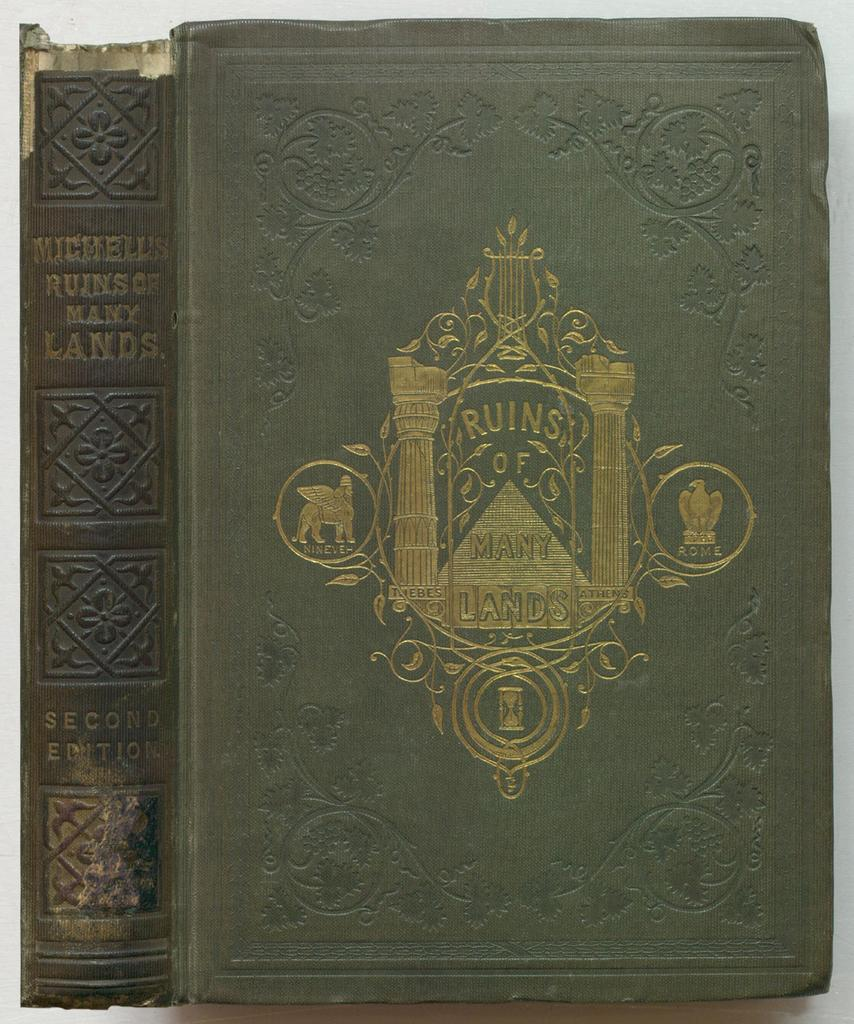<image>
Render a clear and concise summary of the photo. A second Edition of Michelle's Ruins of Many lands sits on a table 